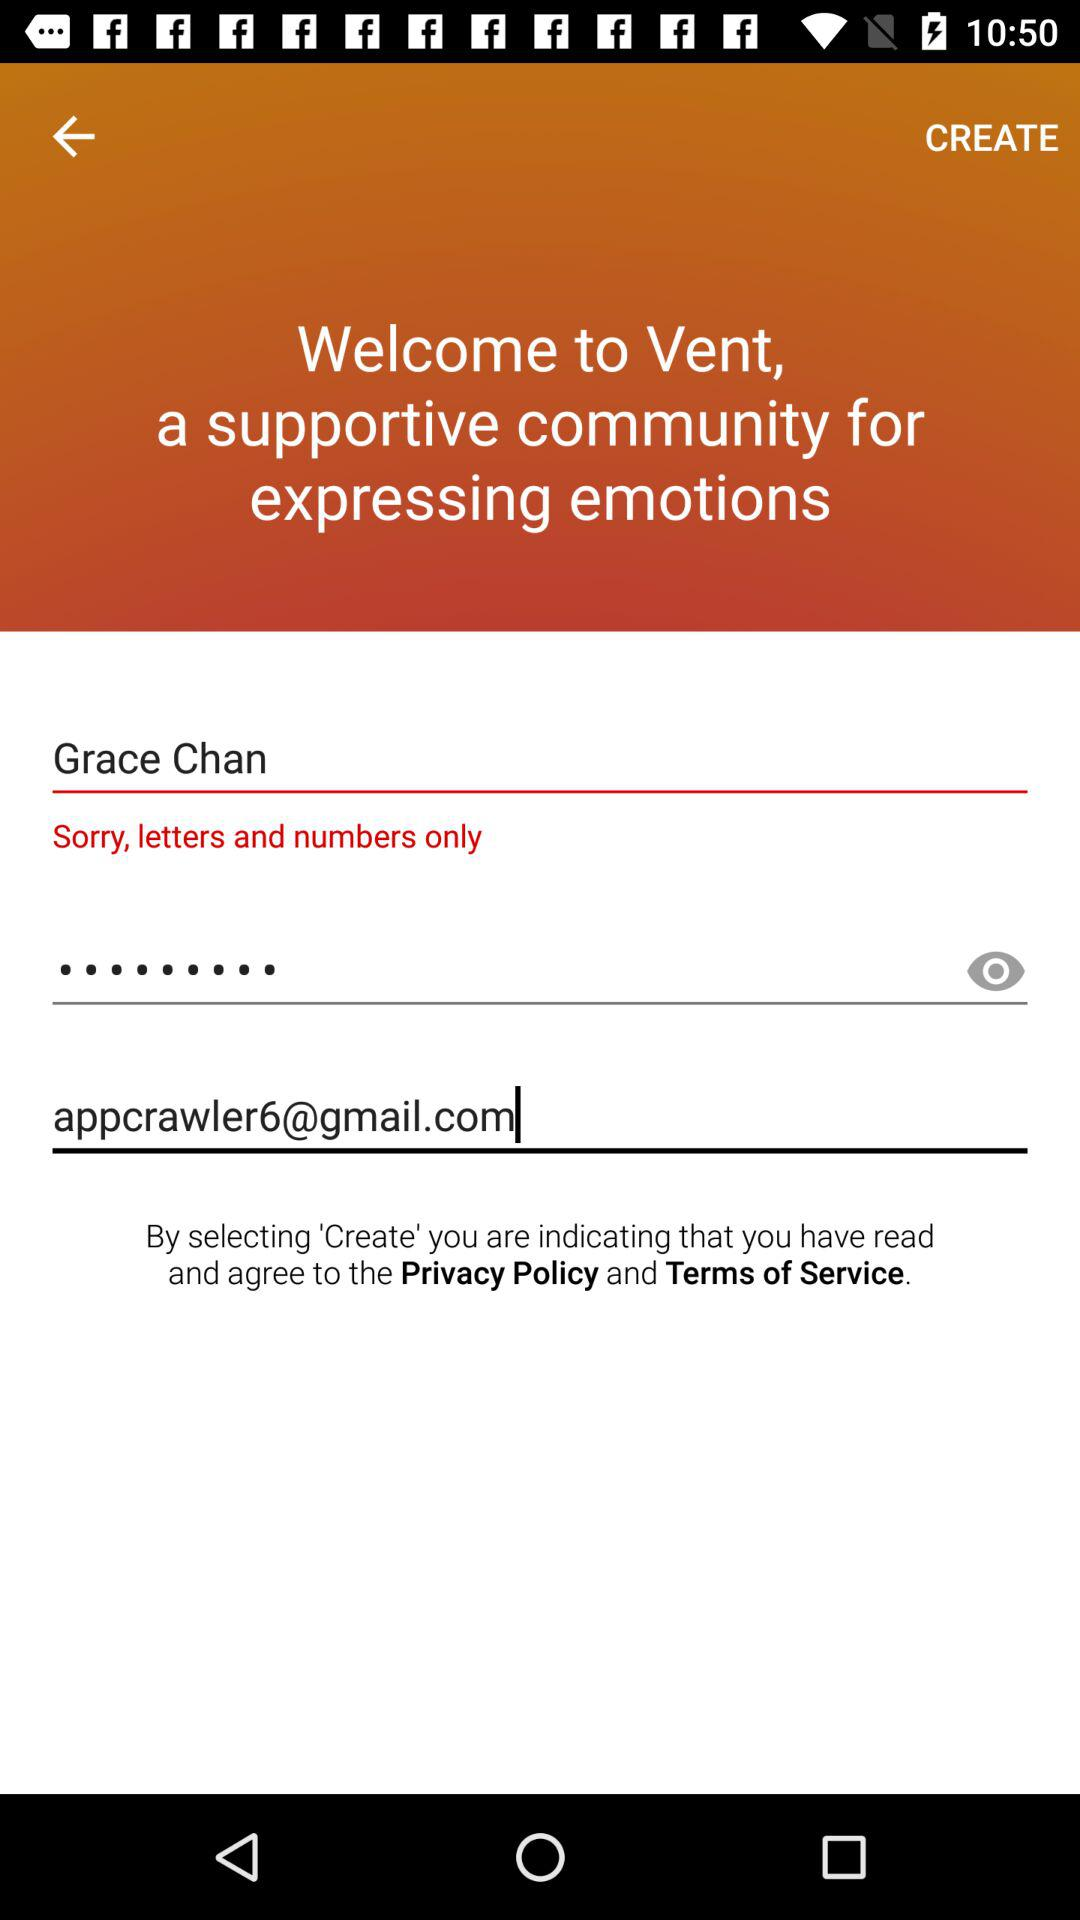How many text input fields are there on this screen?
Answer the question using a single word or phrase. 3 